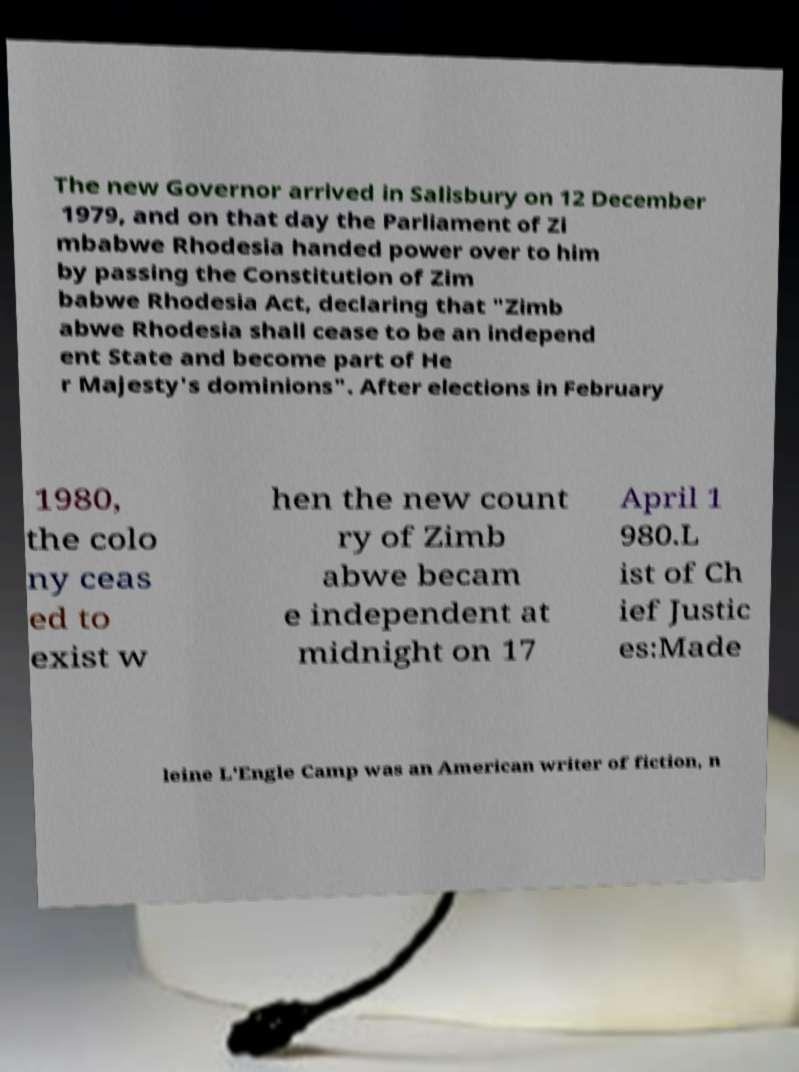There's text embedded in this image that I need extracted. Can you transcribe it verbatim? The new Governor arrived in Salisbury on 12 December 1979, and on that day the Parliament of Zi mbabwe Rhodesia handed power over to him by passing the Constitution of Zim babwe Rhodesia Act, declaring that "Zimb abwe Rhodesia shall cease to be an independ ent State and become part of He r Majesty's dominions". After elections in February 1980, the colo ny ceas ed to exist w hen the new count ry of Zimb abwe becam e independent at midnight on 17 April 1 980.L ist of Ch ief Justic es:Made leine L'Engle Camp was an American writer of fiction, n 